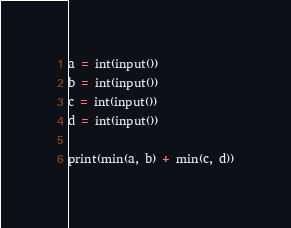Convert code to text. <code><loc_0><loc_0><loc_500><loc_500><_Python_>a = int(input())
b = int(input())
c = int(input())
d = int(input())

print(min(a, b) + min(c, d))</code> 